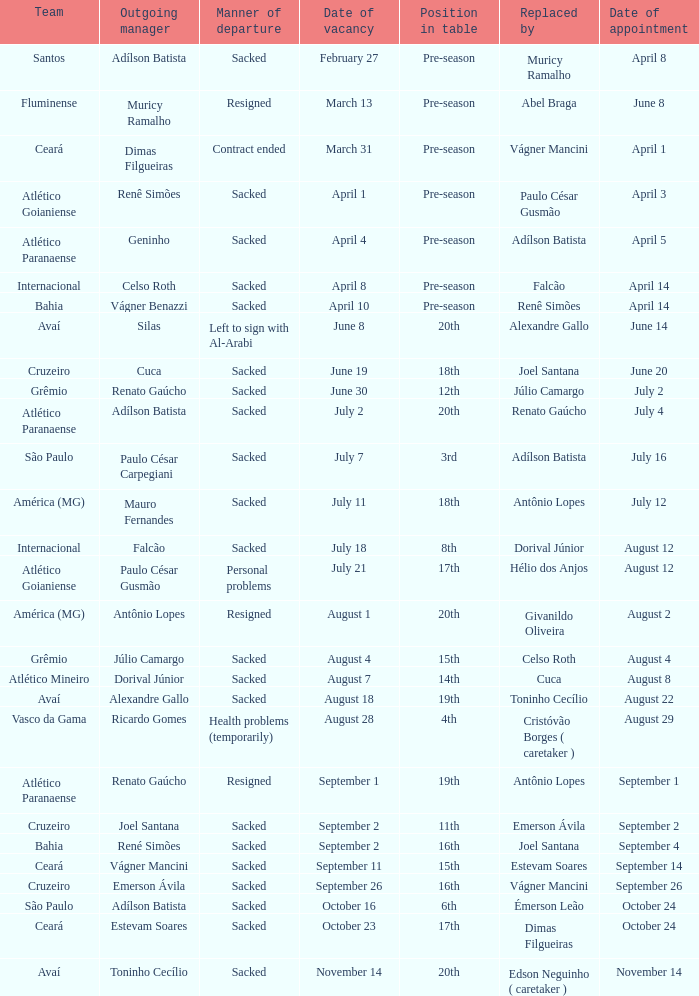How many occasions did silas exit as a team manager? 1.0. 